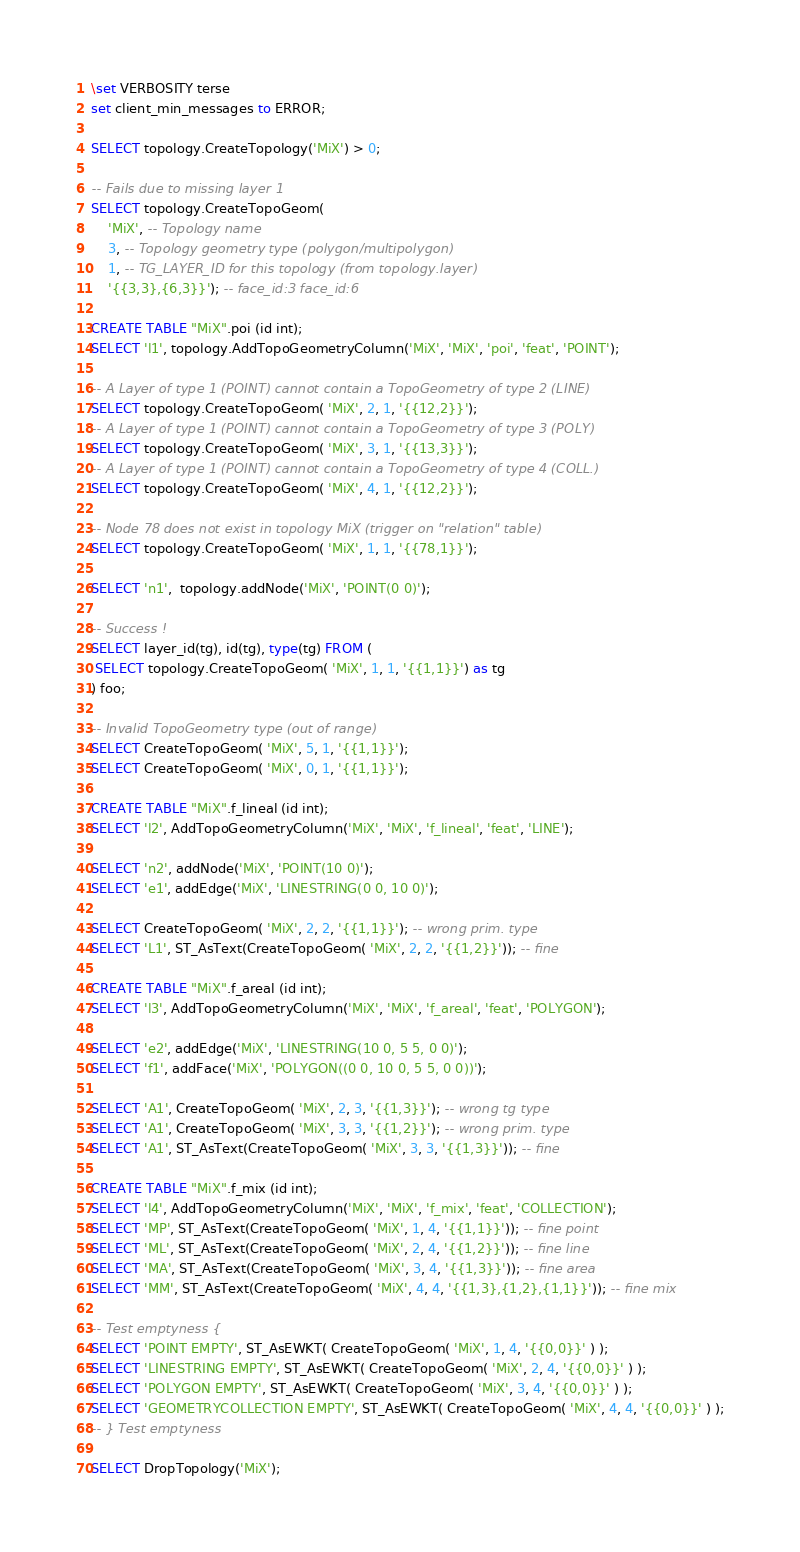Convert code to text. <code><loc_0><loc_0><loc_500><loc_500><_SQL_>\set VERBOSITY terse
set client_min_messages to ERROR;

SELECT topology.CreateTopology('MiX') > 0;

-- Fails due to missing layer 1
SELECT topology.CreateTopoGeom(
    'MiX', -- Topology name
    3, -- Topology geometry type (polygon/multipolygon)
    1, -- TG_LAYER_ID for this topology (from topology.layer)
    '{{3,3},{6,3}}'); -- face_id:3 face_id:6

CREATE TABLE "MiX".poi (id int);
SELECT 'l1', topology.AddTopoGeometryColumn('MiX', 'MiX', 'poi', 'feat', 'POINT');

-- A Layer of type 1 (POINT) cannot contain a TopoGeometry of type 2 (LINE)
SELECT topology.CreateTopoGeom( 'MiX', 2, 1, '{{12,2}}');
-- A Layer of type 1 (POINT) cannot contain a TopoGeometry of type 3 (POLY)
SELECT topology.CreateTopoGeom( 'MiX', 3, 1, '{{13,3}}');
-- A Layer of type 1 (POINT) cannot contain a TopoGeometry of type 4 (COLL.)
SELECT topology.CreateTopoGeom( 'MiX', 4, 1, '{{12,2}}');

-- Node 78 does not exist in topology MiX (trigger on "relation" table)
SELECT topology.CreateTopoGeom( 'MiX', 1, 1, '{{78,1}}');

SELECT 'n1',  topology.addNode('MiX', 'POINT(0 0)');

-- Success !
SELECT layer_id(tg), id(tg), type(tg) FROM (
 SELECT topology.CreateTopoGeom( 'MiX', 1, 1, '{{1,1}}') as tg
) foo;

-- Invalid TopoGeometry type (out of range)
SELECT CreateTopoGeom( 'MiX', 5, 1, '{{1,1}}');
SELECT CreateTopoGeom( 'MiX', 0, 1, '{{1,1}}');

CREATE TABLE "MiX".f_lineal (id int);
SELECT 'l2', AddTopoGeometryColumn('MiX', 'MiX', 'f_lineal', 'feat', 'LINE');

SELECT 'n2', addNode('MiX', 'POINT(10 0)');
SELECT 'e1', addEdge('MiX', 'LINESTRING(0 0, 10 0)');

SELECT CreateTopoGeom( 'MiX', 2, 2, '{{1,1}}'); -- wrong prim. type
SELECT 'L1', ST_AsText(CreateTopoGeom( 'MiX', 2, 2, '{{1,2}}')); -- fine

CREATE TABLE "MiX".f_areal (id int);
SELECT 'l3', AddTopoGeometryColumn('MiX', 'MiX', 'f_areal', 'feat', 'POLYGON');

SELECT 'e2', addEdge('MiX', 'LINESTRING(10 0, 5 5, 0 0)');
SELECT 'f1', addFace('MiX', 'POLYGON((0 0, 10 0, 5 5, 0 0))');

SELECT 'A1', CreateTopoGeom( 'MiX', 2, 3, '{{1,3}}'); -- wrong tg type
SELECT 'A1', CreateTopoGeom( 'MiX', 3, 3, '{{1,2}}'); -- wrong prim. type
SELECT 'A1', ST_AsText(CreateTopoGeom( 'MiX', 3, 3, '{{1,3}}')); -- fine

CREATE TABLE "MiX".f_mix (id int);
SELECT 'l4', AddTopoGeometryColumn('MiX', 'MiX', 'f_mix', 'feat', 'COLLECTION');
SELECT 'MP', ST_AsText(CreateTopoGeom( 'MiX', 1, 4, '{{1,1}}')); -- fine point
SELECT 'ML', ST_AsText(CreateTopoGeom( 'MiX', 2, 4, '{{1,2}}')); -- fine line
SELECT 'MA', ST_AsText(CreateTopoGeom( 'MiX', 3, 4, '{{1,3}}')); -- fine area
SELECT 'MM', ST_AsText(CreateTopoGeom( 'MiX', 4, 4, '{{1,3},{1,2},{1,1}}')); -- fine mix

-- Test emptyness {
SELECT 'POINT EMPTY', ST_AsEWKT( CreateTopoGeom( 'MiX', 1, 4, '{{0,0}}' ) );
SELECT 'LINESTRING EMPTY', ST_AsEWKT( CreateTopoGeom( 'MiX', 2, 4, '{{0,0}}' ) );
SELECT 'POLYGON EMPTY', ST_AsEWKT( CreateTopoGeom( 'MiX', 3, 4, '{{0,0}}' ) );
SELECT 'GEOMETRYCOLLECTION EMPTY', ST_AsEWKT( CreateTopoGeom( 'MiX', 4, 4, '{{0,0}}' ) );
-- } Test emptyness

SELECT DropTopology('MiX');
</code> 